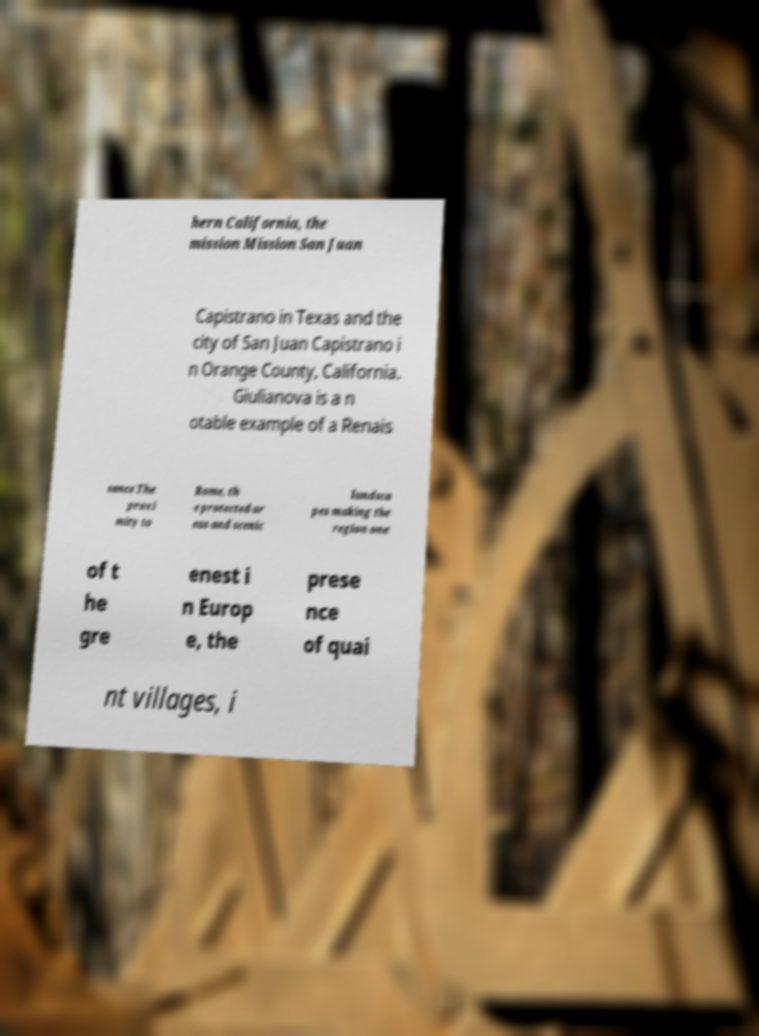What messages or text are displayed in this image? I need them in a readable, typed format. hern California, the mission Mission San Juan Capistrano in Texas and the city of San Juan Capistrano i n Orange County, California. Giulianova is a n otable example of a Renais sance The proxi mity to Rome, th e protected ar eas and scenic landsca pes making the region one of t he gre enest i n Europ e, the prese nce of quai nt villages, i 